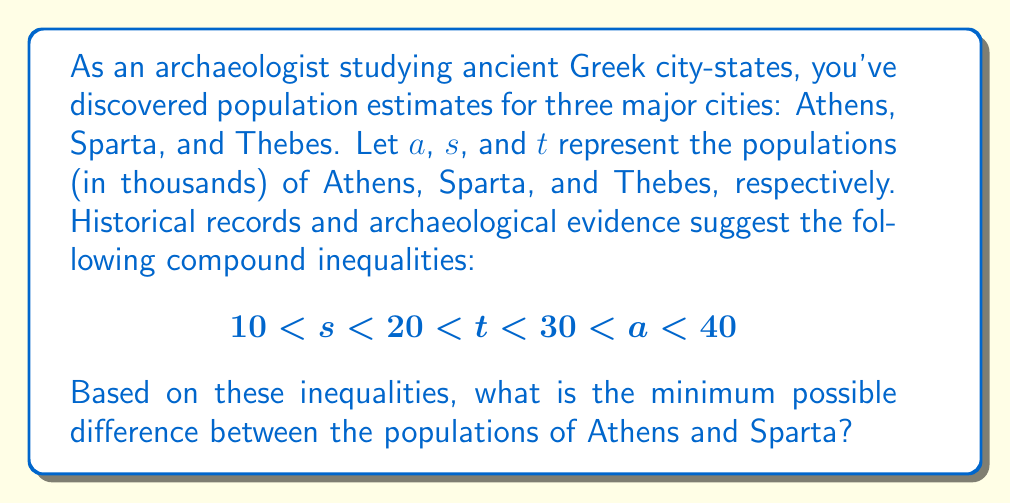Show me your answer to this math problem. To find the minimum possible difference between the populations of Athens and Sparta, we need to consider the extreme values that satisfy the given compound inequalities.

1. For Sparta (s): The minimum value is just above 10,000 ($s > 10$)
2. For Athens (a): The maximum value is just below 40,000 ($a < 40$)

To minimize the difference between Athens and Sparta, we should use:
- The smallest possible value for Athens: just above 30,000
- The largest possible value for Sparta: just below 20,000

Let's represent these values as:
$$a_{min} = 30^+$$
$$s_{max} = 20^-$$

The minimum difference is then:
$$\text{Minimum difference} = a_{min} - s_{max}$$
$$= 30^+ - 20^-$$

This difference is slightly larger than 10,000, as it's the difference between a number just above 30,000 and a number just below 20,000.

Therefore, the minimum possible difference between the populations of Athens and Sparta is 10,000 + ε, where ε represents an infinitesimally small positive number.
Answer: The minimum possible difference between the populations of Athens and Sparta is 10,000 + ε, where ε is an infinitesimally small positive number. 